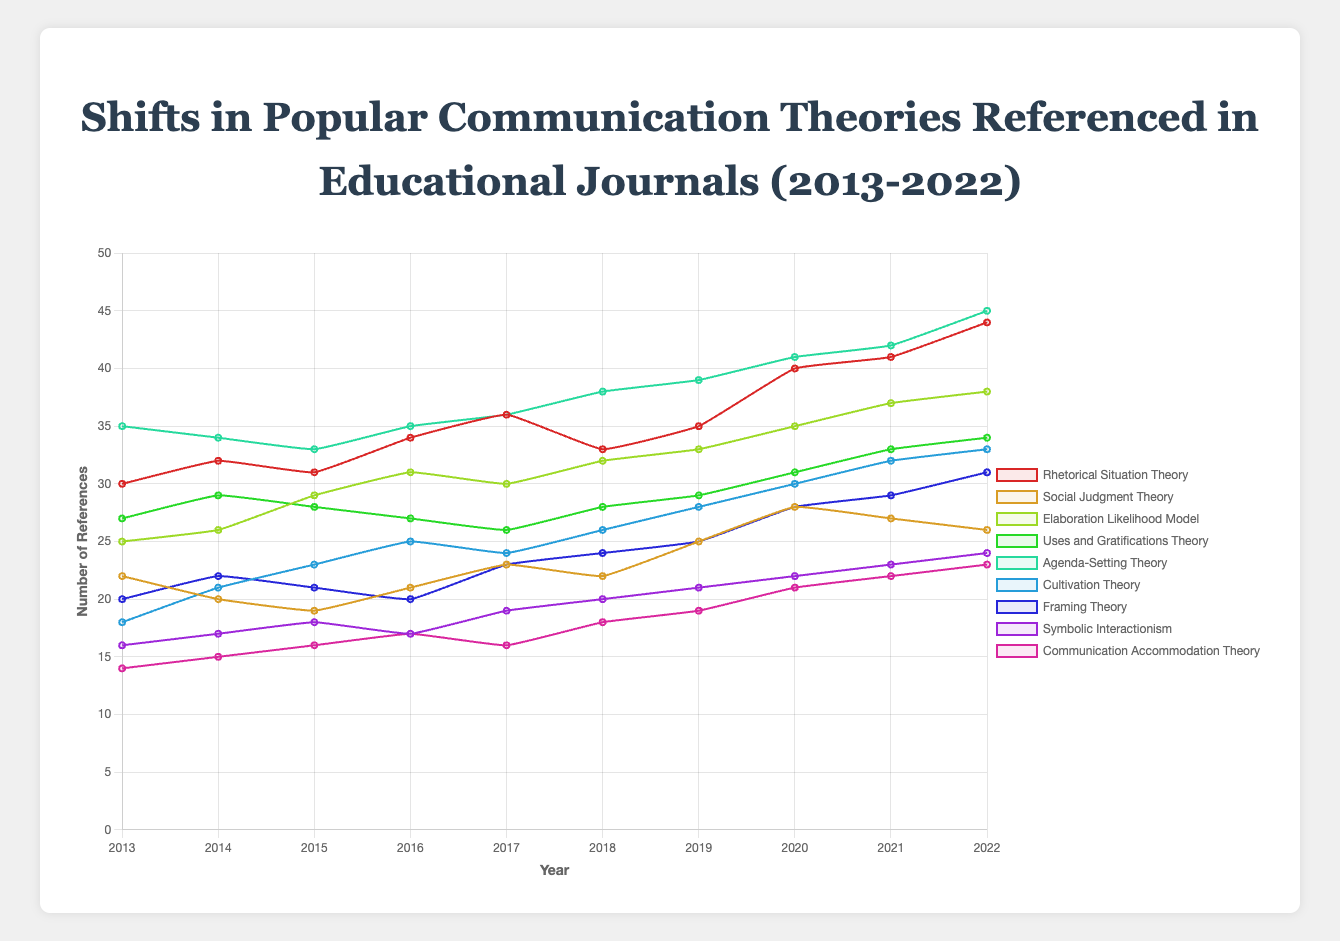How has the popularity of Rhetorical Situation Theory changed from 2013 to 2022? To determine the change in popularity, subtract the number of references in 2013 (30) from the number of references in 2022 (44). 44 - 30 = 14, showing an increase of 14 references.
Answer: Increased by 14 Which theory had the highest number of references in 2022? To find the highest number of references in 2022, compare the last set of reference numbers for all theories. Agenda-Setting Theory has the highest number of references at 45.
Answer: Agenda-Setting Theory Between Social Judgment Theory and Framing Theory, which showed a greater increase in references from 2013 to 2022? Calculate the increase for both theories. For Social Judgment Theory: 26 - 22 = 4. For Framing Theory: 31 - 20 = 11. Framing Theory showed a greater increase.
Answer: Framing Theory On average, how many references did Symbolic Interactionism receive per year? Sum the references from 2013 to 2022: 16 + 17 + 18 + 17 + 19 + 20 + 21 + 22 + 23 + 24 = 197. Divide by 10 years. 197 / 10 = 19.7.
Answer: 19.7 Which theory experienced the largest drop in references in any given year? Compare the year-to-year changes for each theory. Social Judgment Theory dropped from 22 to 20 between 2013 and 2014, with the largest drop of 2.
Answer: Social Judgment Theory What is the difference in the number of references between Elaboration Likelihood Model and Uses and Gratifications Theory in 2020? Subtract the number of references for Uses and Gratifications Theory (31) from Elaboration Likelihood Model (35). 35 - 31 = 4.
Answer: 4 By how much did the number of references for Cultivation Theory increase from 2013 to 2018? Subtract the number of references in 2013 (18) from those in 2018 (26). 26 - 18 = 8.
Answer: 8 Compare the popularity trends of Agenda-Setting Theory and Communication Accommodation Theory. Which one shows steeper growth over the decade? Calculate the total increase for each theory. Agenda-Setting Theory: 45 - 35 = 10. Communication Accommodation Theory: 23 - 14 = 9. Agenda-Setting Theory shows steeper growth.
Answer: Agenda-Setting Theory In which year did Framing Theory have the same number of references as Symbolic Interactionism? Compare yearly references to see when the values match. In 2015, both theories had 18 references.
Answer: 2015 How does the number of references for Rhetorical Situation Theory in 2016 compare to Social Judgment Theory's number of references that year? Compare reference numbers for both theories in 2016. Rhetorical Situation Theory had 34 references, and Social Judgment Theory had 21. Rhetorical Situation Theory had more references.
Answer: Rhetorical Situation Theory had more 